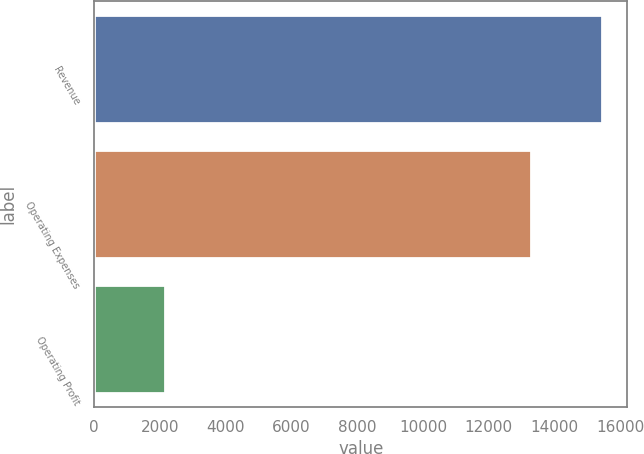<chart> <loc_0><loc_0><loc_500><loc_500><bar_chart><fcel>Revenue<fcel>Operating Expenses<fcel>Operating Profit<nl><fcel>15436.3<fcel>13296.2<fcel>2140.1<nl></chart> 